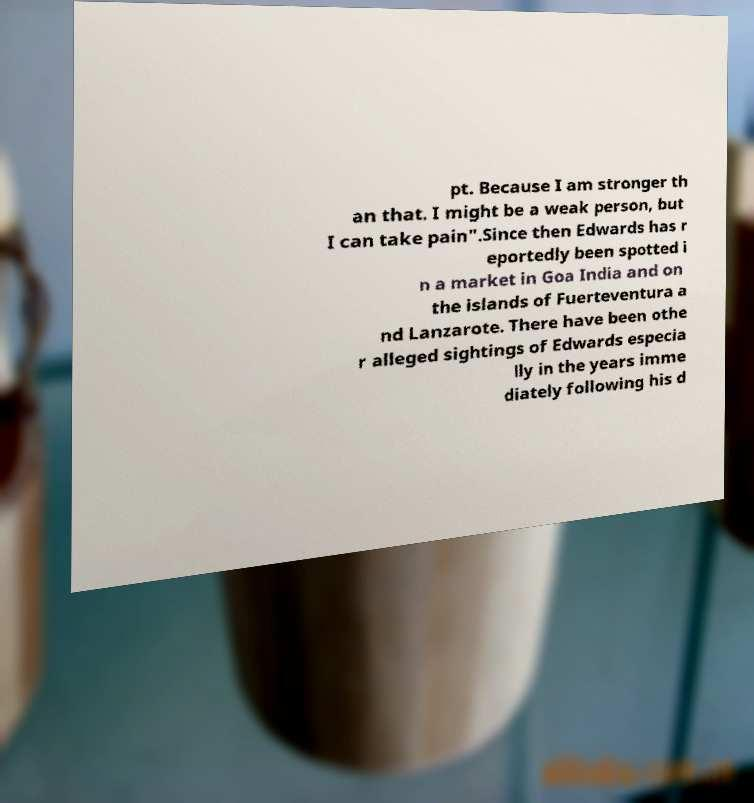Please read and relay the text visible in this image. What does it say? pt. Because I am stronger th an that. I might be a weak person, but I can take pain".Since then Edwards has r eportedly been spotted i n a market in Goa India and on the islands of Fuerteventura a nd Lanzarote. There have been othe r alleged sightings of Edwards especia lly in the years imme diately following his d 